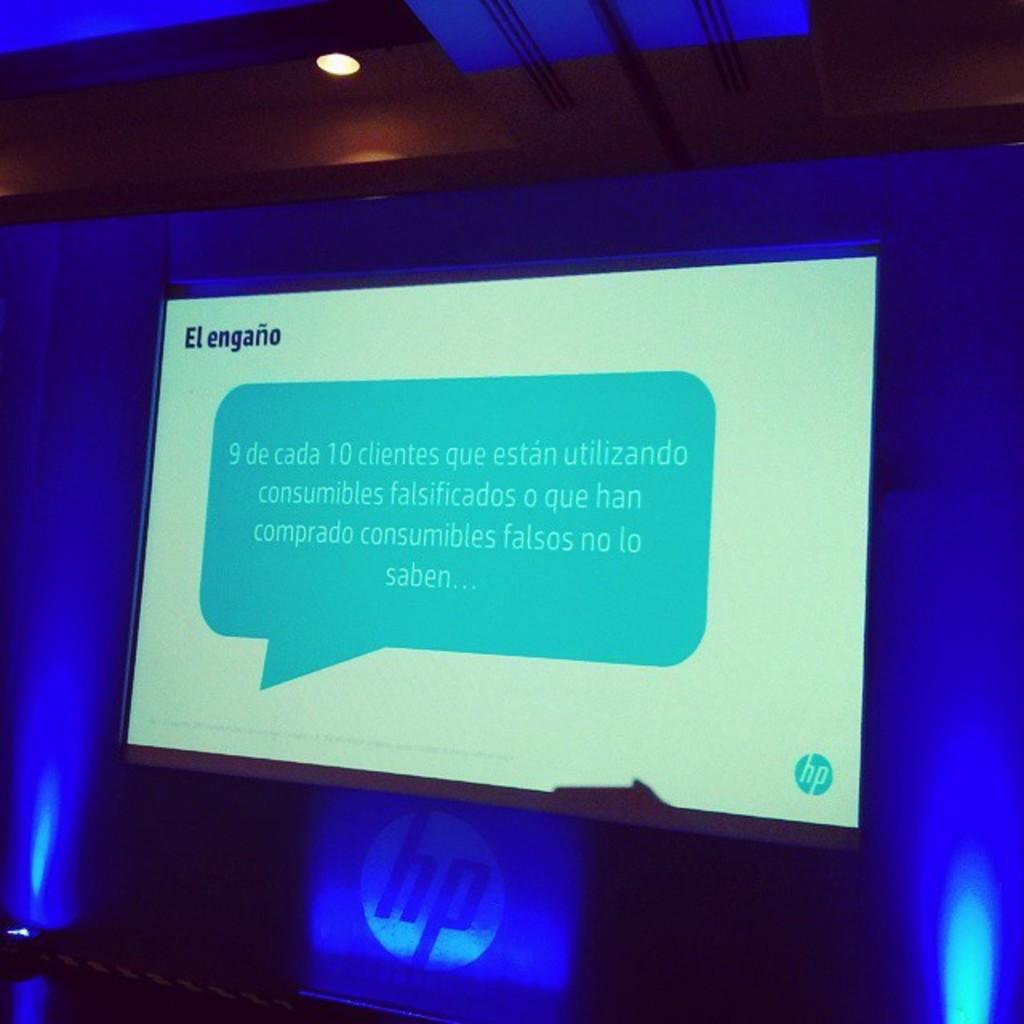Provide a one-sentence caption for the provided image. a computer screen with engano over a blue speech bubble. 